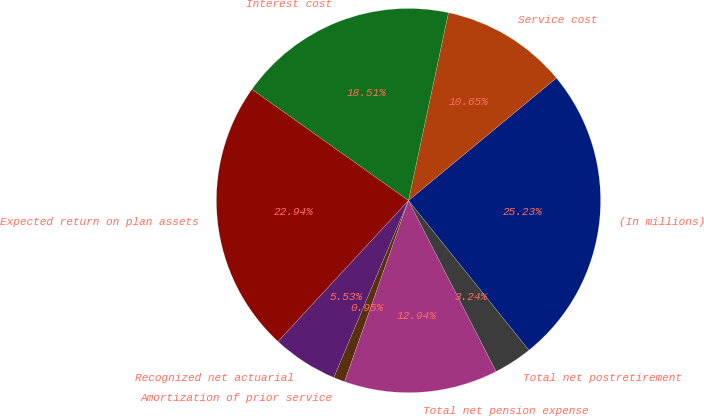<chart> <loc_0><loc_0><loc_500><loc_500><pie_chart><fcel>(In millions)<fcel>Service cost<fcel>Interest cost<fcel>Expected return on plan assets<fcel>Recognized net actuarial<fcel>Amortization of prior service<fcel>Total net pension expense<fcel>Total net postretirement<nl><fcel>25.23%<fcel>10.65%<fcel>18.51%<fcel>22.94%<fcel>5.53%<fcel>0.95%<fcel>12.94%<fcel>3.24%<nl></chart> 